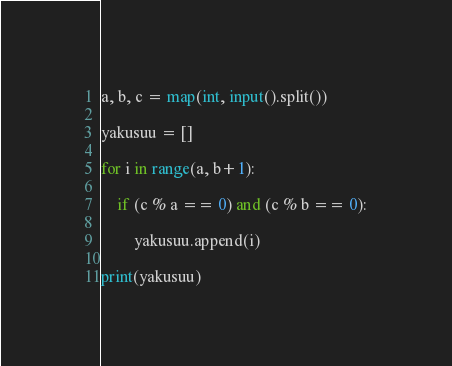Convert code to text. <code><loc_0><loc_0><loc_500><loc_500><_Python_>a, b, c = map(int, input().split())

yakusuu = []

for i in range(a, b+1):

    if (c % a == 0) and (c % b == 0):
 
        yakusuu.append(i)

print(yakusuu)
</code> 